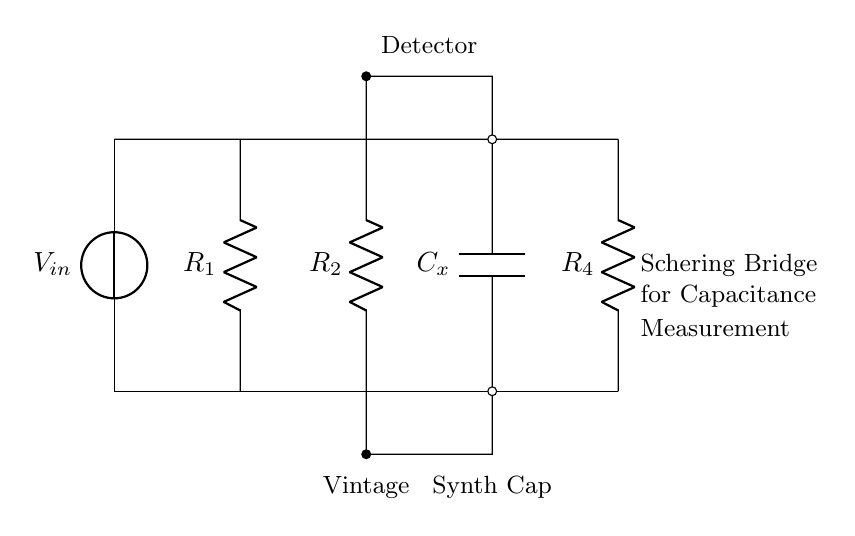What components are used in this circuit? The circuit contains a voltage source, two resistors, a capacitor, and a detector. The key components are indicated in the diagram with labels.
Answer: voltage source, two resistors, capacitor, detector What does the C label indicate? The C label on this circuit diagram represents the component that is a capacitor, specifically the capacitor being measured in this Schering Bridge.
Answer: capacitor How many resistors are present? There are three resistors present in the Schering Bridge circuit, labeled R1, R2, and R4. Each provides different resistance functions.
Answer: three What is the primary function of this circuit? The primary function of this Schering Bridge circuit is to measure the capacitance of an unknown capacitor using a known reference. This is usually done using a method of balancing the bridge.
Answer: measure capacitance Why is the detector placed at the junction of R2 and Cx? The detector is strategically placed at this junction to measure the potential difference in the voltage drop between resistors and the capacitor. This helps determine when the bridge is balanced, which indicates accurate capacitance measurement.
Answer: to measure potential difference What type of bridge is this circuit? This is a Schering Bridge, which is specifically designed for measuring capacitance in electrical components such as vintage synthesizers.
Answer: Schering Bridge What do the labels "Vintage" and "Synth Cap" represent? The labels indicate the specific application of the capacitor being measured within the context of vintage synthesizer components. This helps clarify the circuit's use for music-related electronics.
Answer: vintage synthesizer components 